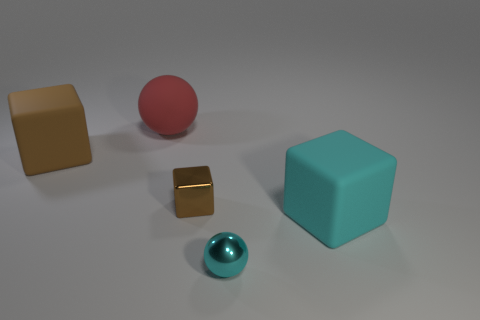There is a ball that is in front of the big red matte thing; does it have the same size as the cube that is right of the small cyan object?
Provide a succinct answer. No. There is a shiny thing that is the same shape as the cyan rubber thing; what is its color?
Provide a succinct answer. Brown. Do the big cyan thing and the tiny brown thing have the same shape?
Keep it short and to the point. Yes. The shiny object that is the same shape as the cyan rubber object is what size?
Offer a very short reply. Small. How many tiny red balls are the same material as the cyan cube?
Ensure brevity in your answer.  0. What number of things are large cyan things or big brown matte things?
Ensure brevity in your answer.  2. There is a matte cube to the right of the big brown block; are there any cyan rubber cubes behind it?
Keep it short and to the point. No. Are there more small brown cubes that are to the right of the brown shiny thing than brown things in front of the big brown rubber cube?
Your answer should be compact. No. There is a object that is the same color as the tiny metallic ball; what material is it?
Offer a very short reply. Rubber. What number of big rubber things have the same color as the metallic cube?
Your response must be concise. 1. 